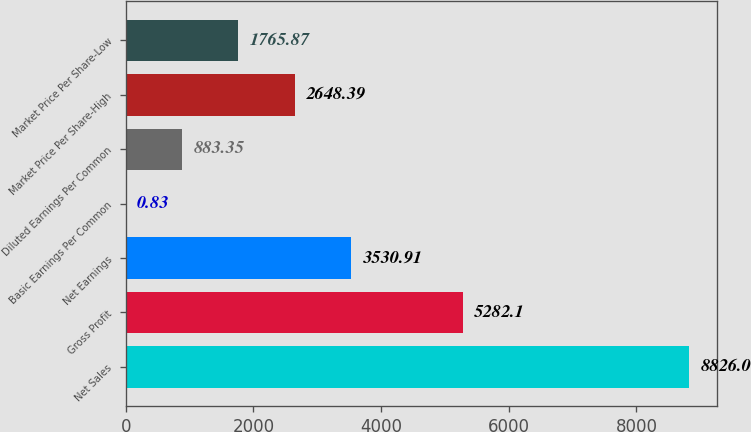<chart> <loc_0><loc_0><loc_500><loc_500><bar_chart><fcel>Net Sales<fcel>Gross Profit<fcel>Net Earnings<fcel>Basic Earnings Per Common<fcel>Diluted Earnings Per Common<fcel>Market Price Per Share-High<fcel>Market Price Per Share-Low<nl><fcel>8826<fcel>5282.1<fcel>3530.91<fcel>0.83<fcel>883.35<fcel>2648.39<fcel>1765.87<nl></chart> 